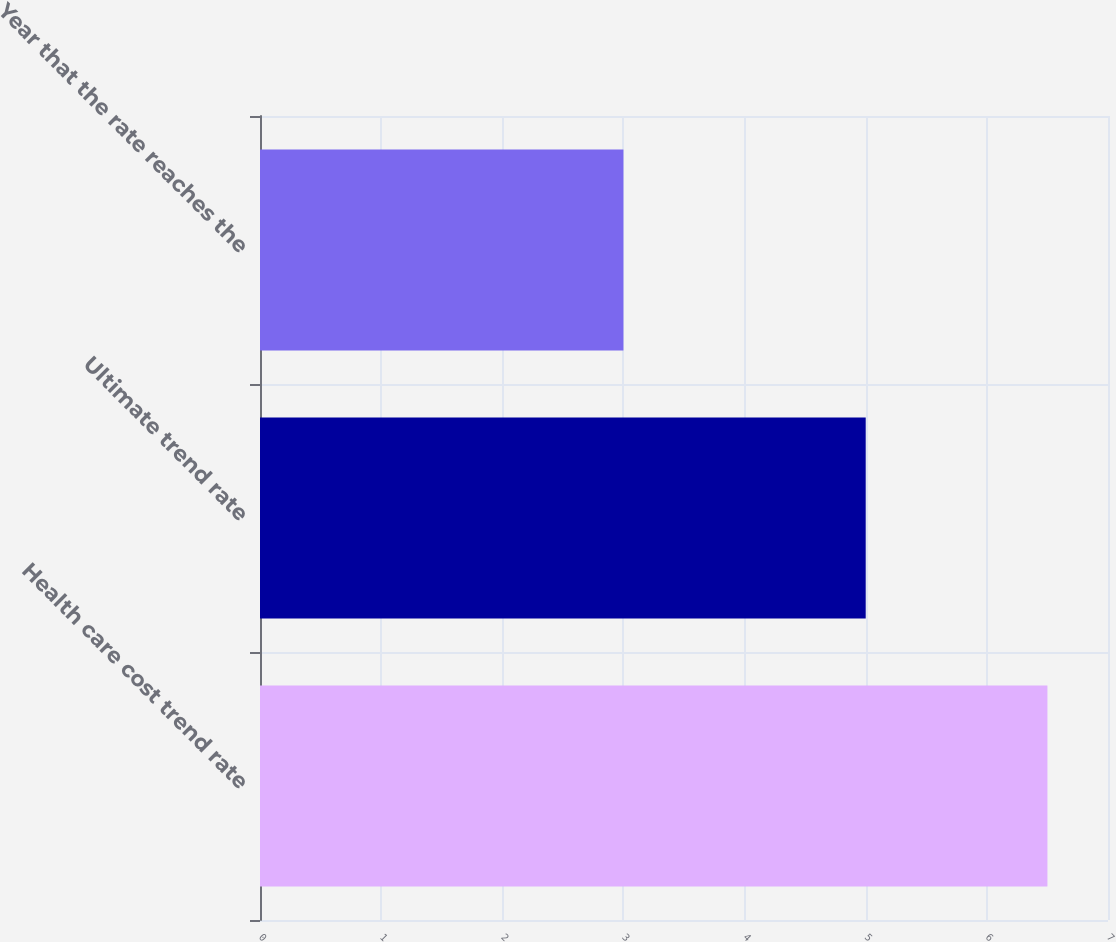Convert chart. <chart><loc_0><loc_0><loc_500><loc_500><bar_chart><fcel>Health care cost trend rate<fcel>Ultimate trend rate<fcel>Year that the rate reaches the<nl><fcel>6.5<fcel>5<fcel>3<nl></chart> 